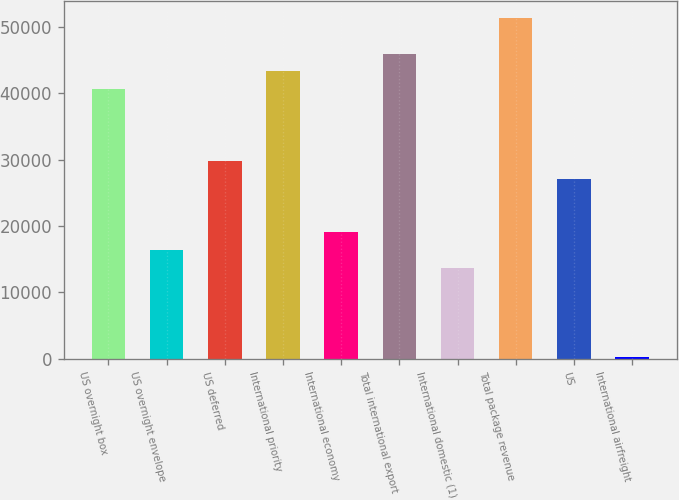Convert chart. <chart><loc_0><loc_0><loc_500><loc_500><bar_chart><fcel>US overnight box<fcel>US overnight envelope<fcel>US deferred<fcel>International priority<fcel>International economy<fcel>Total international export<fcel>International domestic (1)<fcel>Total package revenue<fcel>US<fcel>International airfreight<nl><fcel>40618.5<fcel>16413<fcel>29860.5<fcel>43308<fcel>19102.5<fcel>45997.5<fcel>13723.5<fcel>51376.5<fcel>27171<fcel>276<nl></chart> 